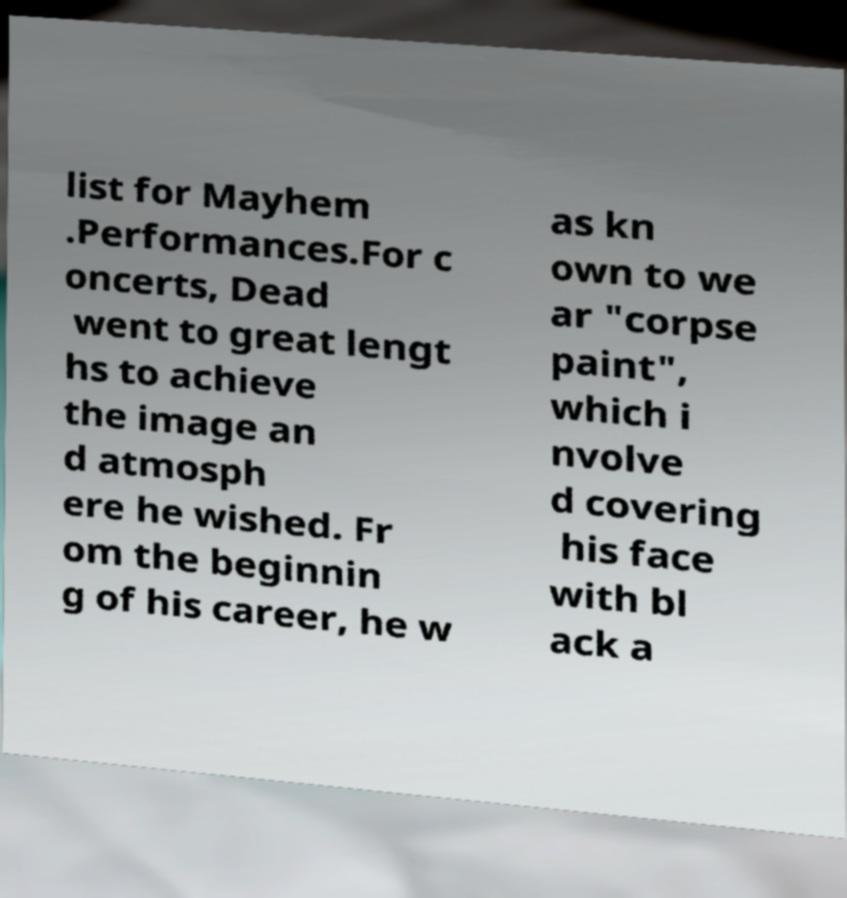I need the written content from this picture converted into text. Can you do that? list for Mayhem .Performances.For c oncerts, Dead went to great lengt hs to achieve the image an d atmosph ere he wished. Fr om the beginnin g of his career, he w as kn own to we ar "corpse paint", which i nvolve d covering his face with bl ack a 